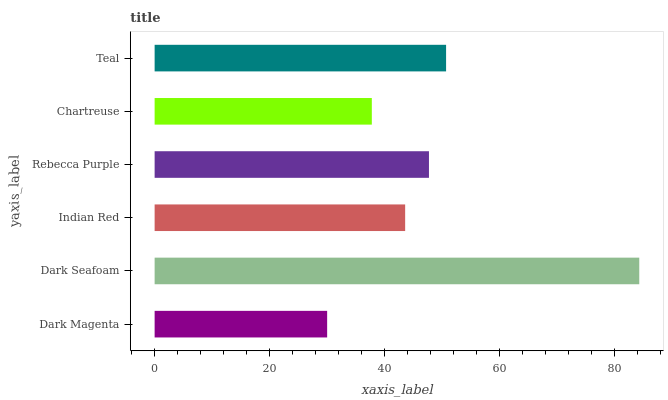Is Dark Magenta the minimum?
Answer yes or no. Yes. Is Dark Seafoam the maximum?
Answer yes or no. Yes. Is Indian Red the minimum?
Answer yes or no. No. Is Indian Red the maximum?
Answer yes or no. No. Is Dark Seafoam greater than Indian Red?
Answer yes or no. Yes. Is Indian Red less than Dark Seafoam?
Answer yes or no. Yes. Is Indian Red greater than Dark Seafoam?
Answer yes or no. No. Is Dark Seafoam less than Indian Red?
Answer yes or no. No. Is Rebecca Purple the high median?
Answer yes or no. Yes. Is Indian Red the low median?
Answer yes or no. Yes. Is Dark Seafoam the high median?
Answer yes or no. No. Is Dark Magenta the low median?
Answer yes or no. No. 